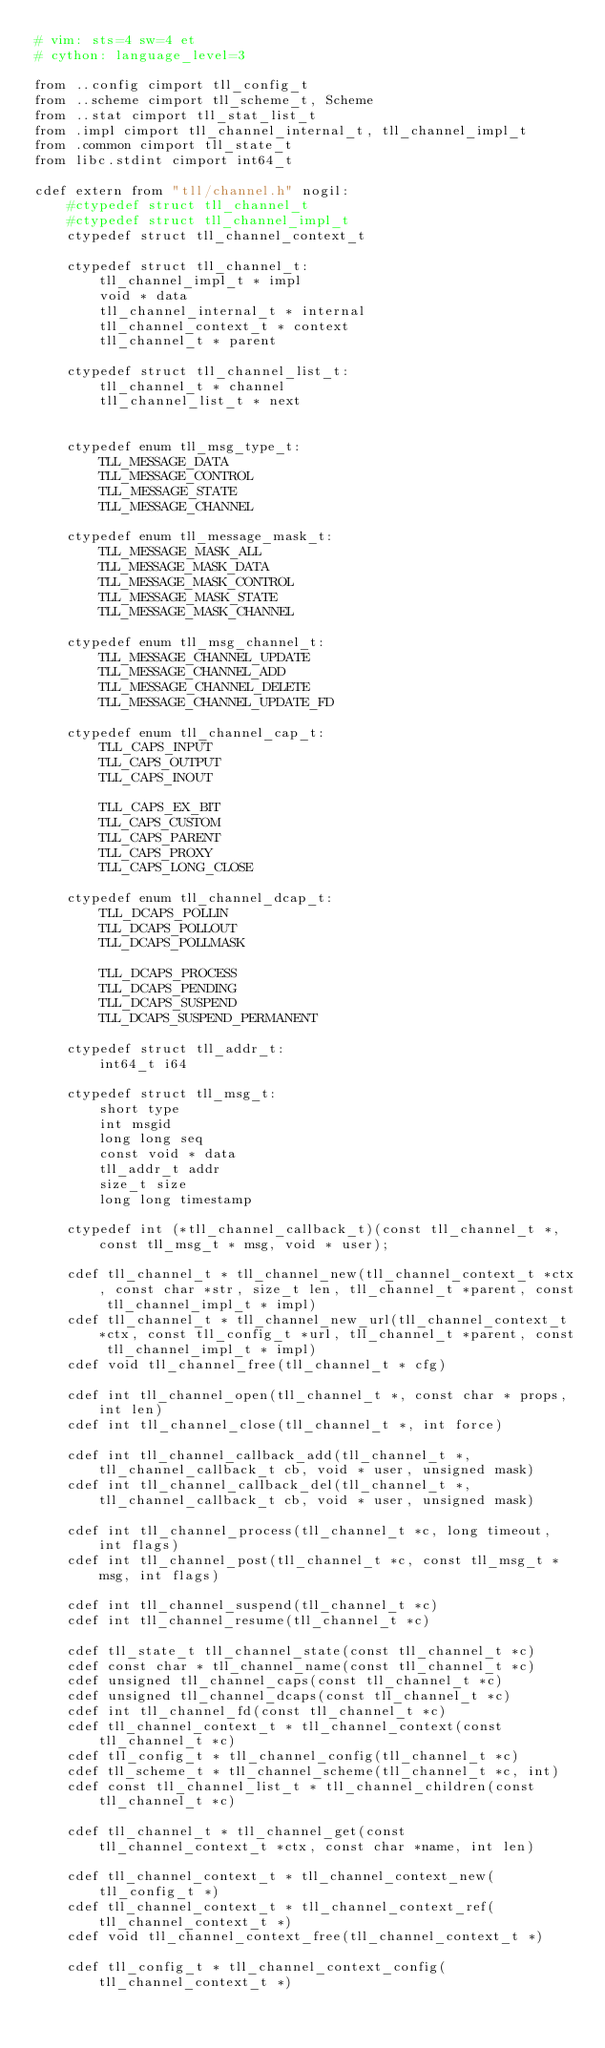<code> <loc_0><loc_0><loc_500><loc_500><_Cython_># vim: sts=4 sw=4 et
# cython: language_level=3

from ..config cimport tll_config_t
from ..scheme cimport tll_scheme_t, Scheme
from ..stat cimport tll_stat_list_t
from .impl cimport tll_channel_internal_t, tll_channel_impl_t
from .common cimport tll_state_t
from libc.stdint cimport int64_t

cdef extern from "tll/channel.h" nogil:
    #ctypedef struct tll_channel_t
    #ctypedef struct tll_channel_impl_t
    ctypedef struct tll_channel_context_t

    ctypedef struct tll_channel_t:
        tll_channel_impl_t * impl
        void * data
        tll_channel_internal_t * internal
        tll_channel_context_t * context
        tll_channel_t * parent

    ctypedef struct tll_channel_list_t:
        tll_channel_t * channel
        tll_channel_list_t * next


    ctypedef enum tll_msg_type_t:
        TLL_MESSAGE_DATA
        TLL_MESSAGE_CONTROL
        TLL_MESSAGE_STATE
        TLL_MESSAGE_CHANNEL

    ctypedef enum tll_message_mask_t:
        TLL_MESSAGE_MASK_ALL
        TLL_MESSAGE_MASK_DATA
        TLL_MESSAGE_MASK_CONTROL
        TLL_MESSAGE_MASK_STATE
        TLL_MESSAGE_MASK_CHANNEL

    ctypedef enum tll_msg_channel_t:
        TLL_MESSAGE_CHANNEL_UPDATE
        TLL_MESSAGE_CHANNEL_ADD
        TLL_MESSAGE_CHANNEL_DELETE
        TLL_MESSAGE_CHANNEL_UPDATE_FD

    ctypedef enum tll_channel_cap_t:
        TLL_CAPS_INPUT
        TLL_CAPS_OUTPUT
        TLL_CAPS_INOUT

        TLL_CAPS_EX_BIT
        TLL_CAPS_CUSTOM
        TLL_CAPS_PARENT
        TLL_CAPS_PROXY
        TLL_CAPS_LONG_CLOSE

    ctypedef enum tll_channel_dcap_t:
        TLL_DCAPS_POLLIN
        TLL_DCAPS_POLLOUT
        TLL_DCAPS_POLLMASK

        TLL_DCAPS_PROCESS
        TLL_DCAPS_PENDING
        TLL_DCAPS_SUSPEND
        TLL_DCAPS_SUSPEND_PERMANENT

    ctypedef struct tll_addr_t:
        int64_t i64

    ctypedef struct tll_msg_t:
        short type
        int msgid
        long long seq
        const void * data
        tll_addr_t addr
        size_t size
        long long timestamp

    ctypedef int (*tll_channel_callback_t)(const tll_channel_t *, const tll_msg_t * msg, void * user);

    cdef tll_channel_t * tll_channel_new(tll_channel_context_t *ctx, const char *str, size_t len, tll_channel_t *parent, const tll_channel_impl_t * impl)
    cdef tll_channel_t * tll_channel_new_url(tll_channel_context_t *ctx, const tll_config_t *url, tll_channel_t *parent, const tll_channel_impl_t * impl)
    cdef void tll_channel_free(tll_channel_t * cfg)

    cdef int tll_channel_open(tll_channel_t *, const char * props, int len)
    cdef int tll_channel_close(tll_channel_t *, int force)

    cdef int tll_channel_callback_add(tll_channel_t *, tll_channel_callback_t cb, void * user, unsigned mask)
    cdef int tll_channel_callback_del(tll_channel_t *, tll_channel_callback_t cb, void * user, unsigned mask)

    cdef int tll_channel_process(tll_channel_t *c, long timeout, int flags)
    cdef int tll_channel_post(tll_channel_t *c, const tll_msg_t *msg, int flags)

    cdef int tll_channel_suspend(tll_channel_t *c)
    cdef int tll_channel_resume(tll_channel_t *c)

    cdef tll_state_t tll_channel_state(const tll_channel_t *c)
    cdef const char * tll_channel_name(const tll_channel_t *c)
    cdef unsigned tll_channel_caps(const tll_channel_t *c)
    cdef unsigned tll_channel_dcaps(const tll_channel_t *c)
    cdef int tll_channel_fd(const tll_channel_t *c)
    cdef tll_channel_context_t * tll_channel_context(const tll_channel_t *c)
    cdef tll_config_t * tll_channel_config(tll_channel_t *c)
    cdef tll_scheme_t * tll_channel_scheme(tll_channel_t *c, int)
    cdef const tll_channel_list_t * tll_channel_children(const tll_channel_t *c)

    cdef tll_channel_t * tll_channel_get(const tll_channel_context_t *ctx, const char *name, int len)

    cdef tll_channel_context_t * tll_channel_context_new(tll_config_t *)
    cdef tll_channel_context_t * tll_channel_context_ref(tll_channel_context_t *)
    cdef void tll_channel_context_free(tll_channel_context_t *)

    cdef tll_config_t * tll_channel_context_config(tll_channel_context_t *)</code> 